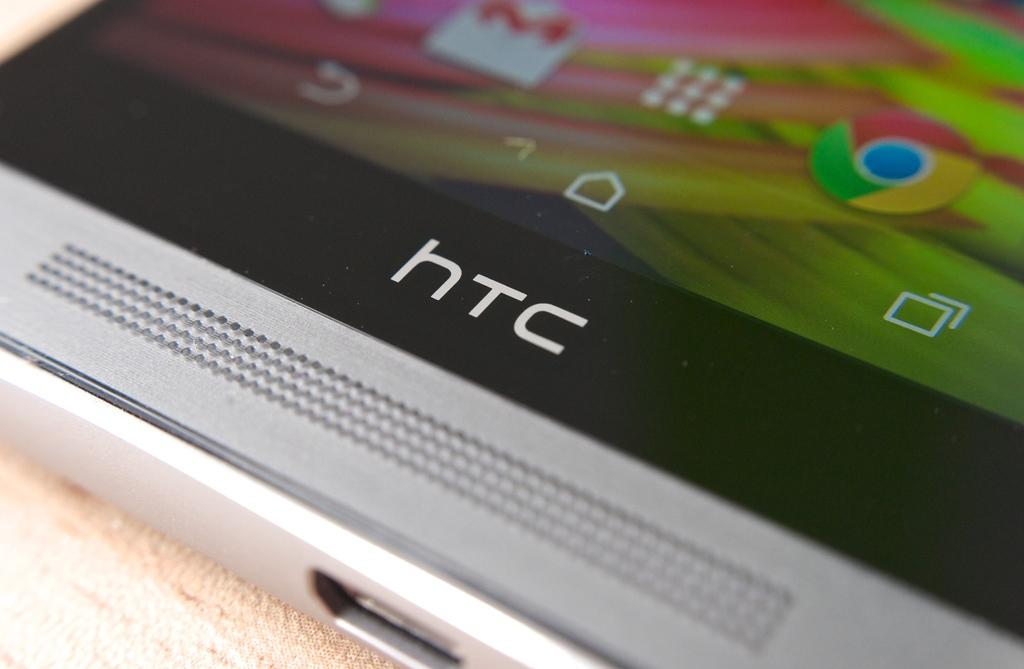<image>
Describe the image concisely. An HTC phone is displayed with Google Chrome and Gmail apps on the screen 